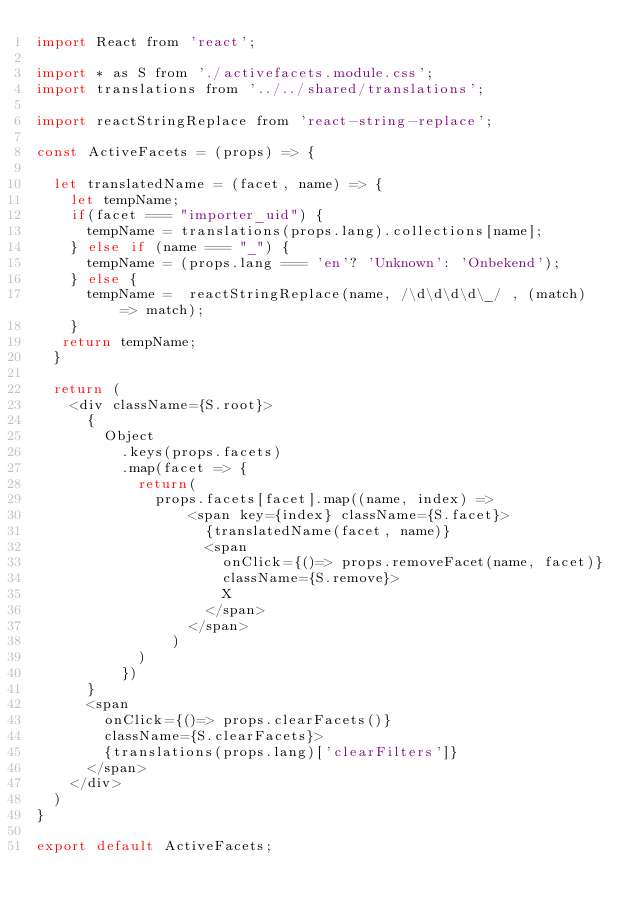Convert code to text. <code><loc_0><loc_0><loc_500><loc_500><_JavaScript_>import React from 'react';

import * as S from './activefacets.module.css';
import translations from '../../shared/translations';

import reactStringReplace from 'react-string-replace';

const ActiveFacets = (props) => {
 
  let translatedName = (facet, name) => {
    let tempName;
    if(facet === "importer_uid") {
      tempName = translations(props.lang).collections[name];
    } else if (name === "_") {
      tempName = (props.lang === 'en'? 'Unknown': 'Onbekend');
    } else {
      tempName =  reactStringReplace(name, /\d\d\d\d\_/ , (match) => match);
    }
   return tempName;
  }
  
  return (
    <div className={S.root}>
      { 
        Object
          .keys(props.facets)
          .map(facet => {
            return(
              props.facets[facet].map((name, index) => 
                  <span key={index} className={S.facet}>
                    {translatedName(facet, name)}
                    <span 
                      onClick={()=> props.removeFacet(name, facet)}
                      className={S.remove}>
                      X
                    </span>
                  </span>
                )
            )
          })
      }
      <span 
        onClick={()=> props.clearFacets()}
        className={S.clearFacets}>
        {translations(props.lang)['clearFilters']}
      </span>
    </div>
  )
}

export default ActiveFacets;</code> 